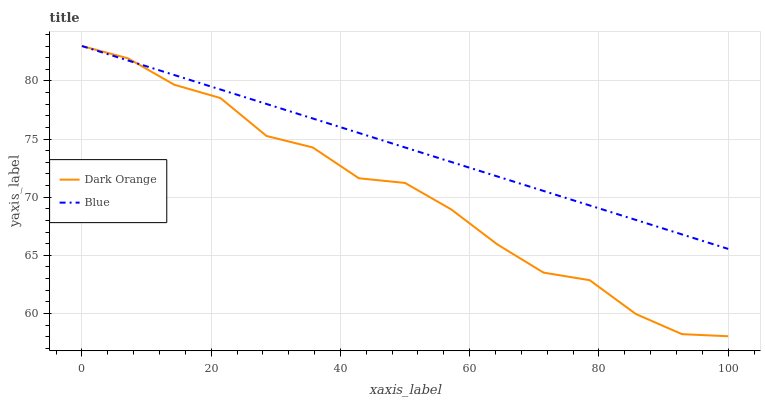Does Dark Orange have the minimum area under the curve?
Answer yes or no. Yes. Does Blue have the maximum area under the curve?
Answer yes or no. Yes. Does Dark Orange have the maximum area under the curve?
Answer yes or no. No. Is Blue the smoothest?
Answer yes or no. Yes. Is Dark Orange the roughest?
Answer yes or no. Yes. Is Dark Orange the smoothest?
Answer yes or no. No. Does Dark Orange have the lowest value?
Answer yes or no. Yes. Does Dark Orange have the highest value?
Answer yes or no. Yes. Does Blue intersect Dark Orange?
Answer yes or no. Yes. Is Blue less than Dark Orange?
Answer yes or no. No. Is Blue greater than Dark Orange?
Answer yes or no. No. 